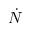<formula> <loc_0><loc_0><loc_500><loc_500>\dot { N }</formula> 